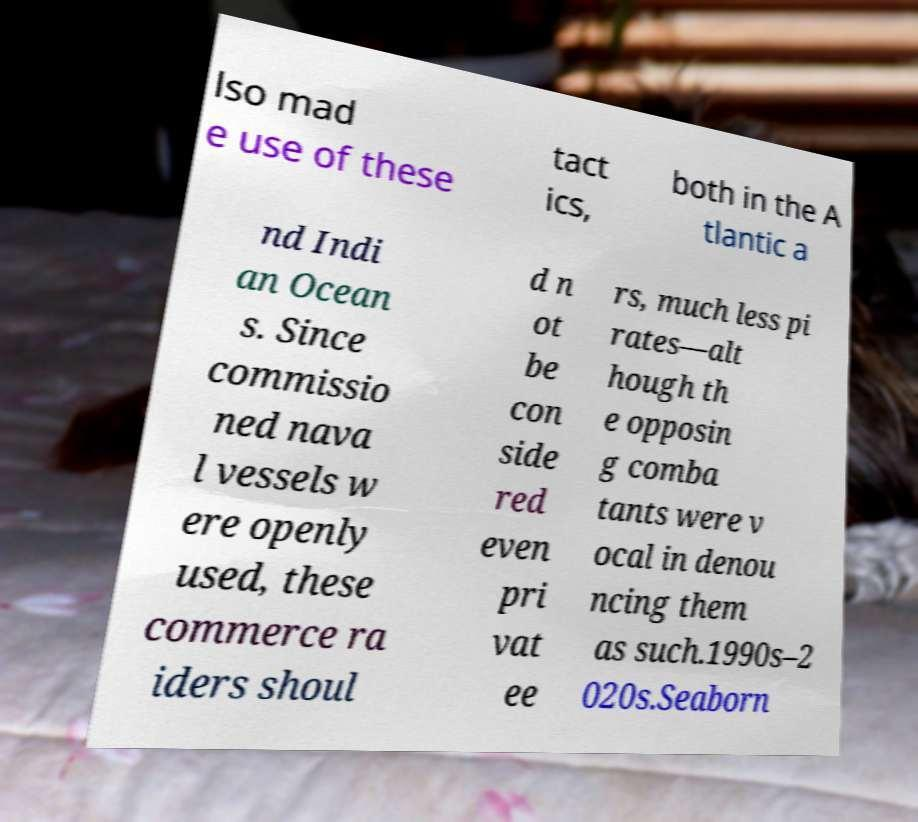Could you extract and type out the text from this image? lso mad e use of these tact ics, both in the A tlantic a nd Indi an Ocean s. Since commissio ned nava l vessels w ere openly used, these commerce ra iders shoul d n ot be con side red even pri vat ee rs, much less pi rates—alt hough th e opposin g comba tants were v ocal in denou ncing them as such.1990s–2 020s.Seaborn 